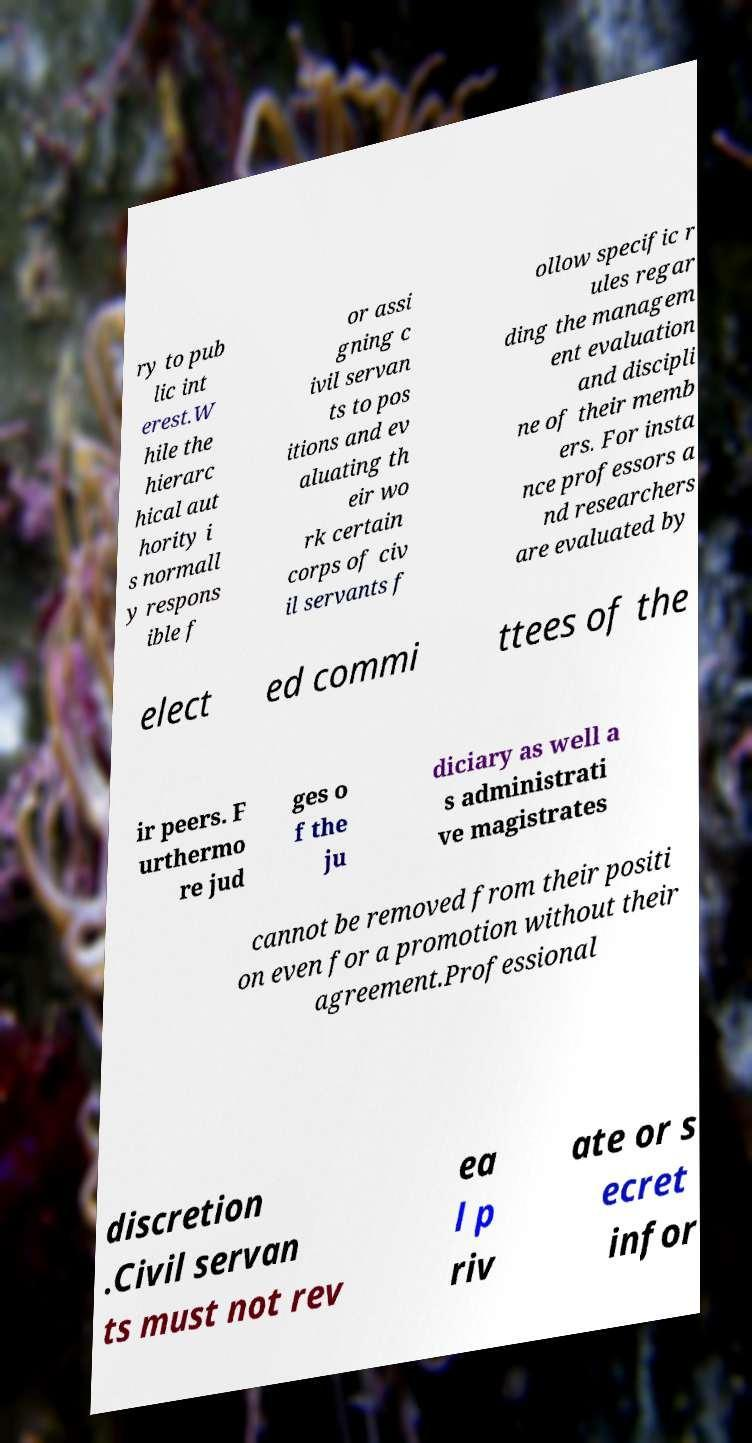What messages or text are displayed in this image? I need them in a readable, typed format. ry to pub lic int erest.W hile the hierarc hical aut hority i s normall y respons ible f or assi gning c ivil servan ts to pos itions and ev aluating th eir wo rk certain corps of civ il servants f ollow specific r ules regar ding the managem ent evaluation and discipli ne of their memb ers. For insta nce professors a nd researchers are evaluated by elect ed commi ttees of the ir peers. F urthermo re jud ges o f the ju diciary as well a s administrati ve magistrates cannot be removed from their positi on even for a promotion without their agreement.Professional discretion .Civil servan ts must not rev ea l p riv ate or s ecret infor 